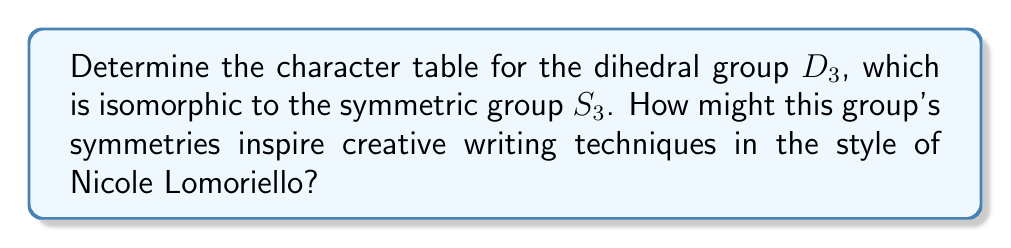Teach me how to tackle this problem. To determine the character table for $D_3$, we'll follow these steps:

1) First, identify the conjugacy classes of $D_3$:
   $C_1 = \{e\}$ (identity)
   $C_2 = \{r, r^2\}$ (rotations)
   $C_3 = \{s, sr, sr^2\}$ (reflections)

2) The number of irreducible representations is equal to the number of conjugacy classes, so we have 3 irreducible representations.

3) We know that $\sum_i (\dim \rho_i)^2 = |G| = 6$, where $\rho_i$ are the irreducible representations. The only way to satisfy this is with dimensions 1, 1, and 2.

4) Let's call these representations $\rho_1$, $\rho_2$, and $\rho_3$ respectively.

5) $\rho_1$ is always the trivial representation, with character 1 for all elements.

6) For $\rho_2$, we need a 1-dimensional representation that's not trivial. It must send rotations to 1 and reflections to -1.

7) For $\rho_3$, we can determine its character values using orthogonality relations and the fact that the sum of squares of dimensions equals the order of the group.

The resulting character table is:

$$
\begin{array}{c|ccc}
D_3 & C_1 & C_2 & C_3 \\
\hline
\rho_1 & 1 & 1 & 1 \\
\rho_2 & 1 & 1 & -1 \\
\rho_3 & 2 & -1 & 0
\end{array}
$$

This symmetry group could inspire writing techniques by considering:
- Three distinct "voices" or perspectives (like the three irreducible representations)
- Cyclical narrative structures (like the rotations)
- Reflection or mirroring in plot or character development (like the reflections in $D_3$)
- Balancing contrasting elements in the story (like the interplay between rotations and reflections)
Answer: Character table for $D_3$:
$$
\begin{array}{c|ccc}
D_3 & C_1 & C_2 & C_3 \\
\hline
\rho_1 & 1 & 1 & 1 \\
\rho_2 & 1 & 1 & -1 \\
\rho_3 & 2 & -1 & 0
\end{array}
$$ 